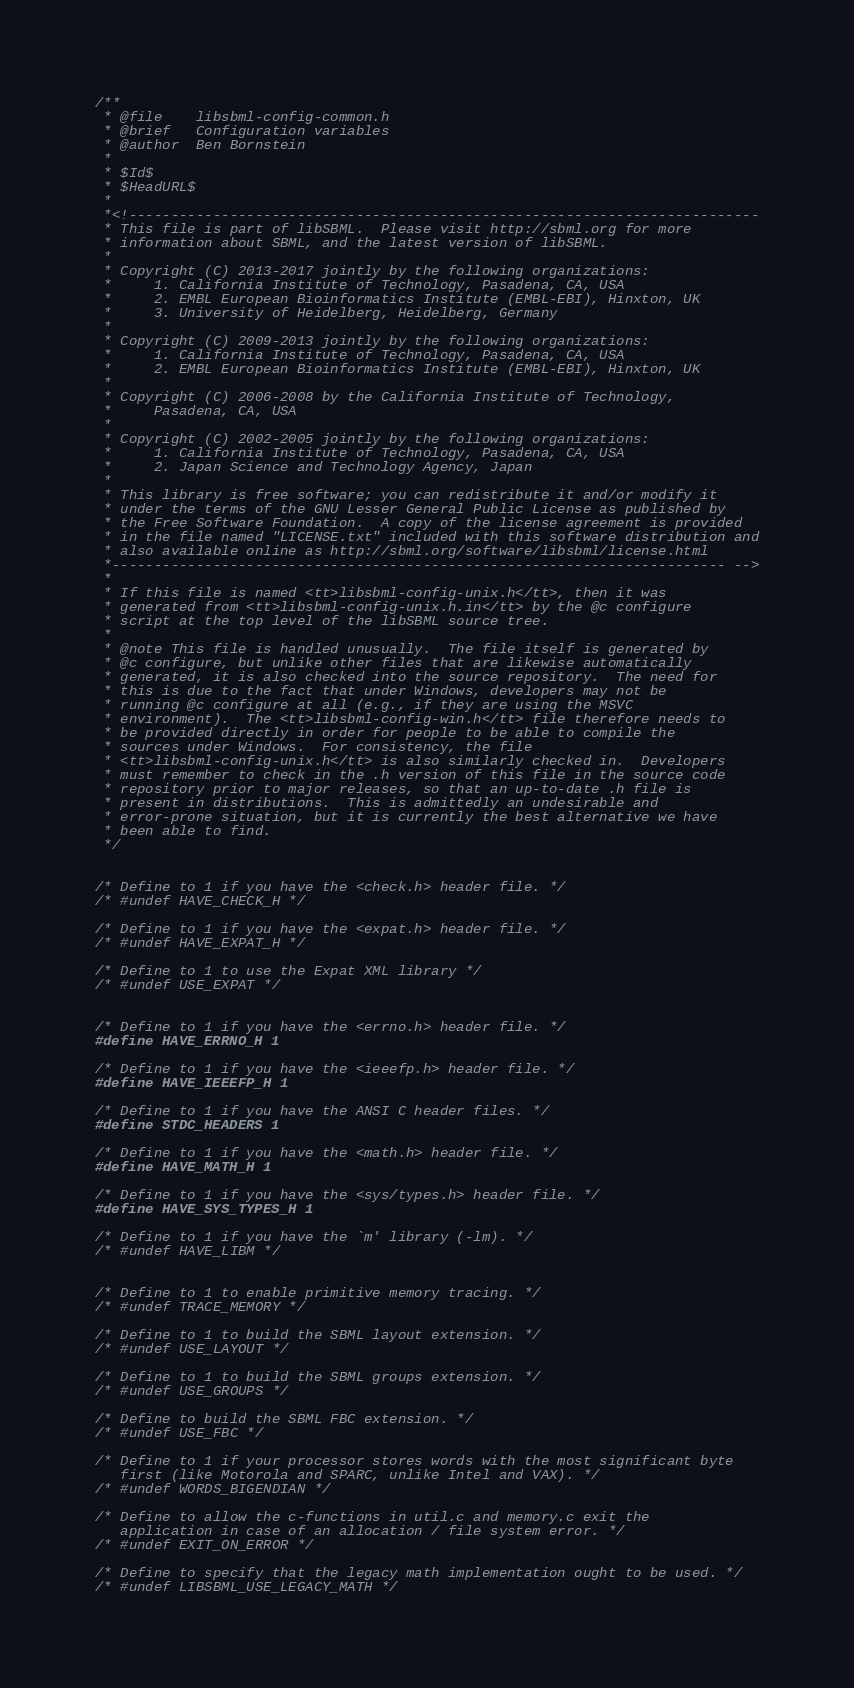Convert code to text. <code><loc_0><loc_0><loc_500><loc_500><_C_>/**
 * @file    libsbml-config-common.h
 * @brief   Configuration variables 
 * @author  Ben Bornstein
 *
 * $Id$
 * $HeadURL$
 *
 *<!---------------------------------------------------------------------------
 * This file is part of libSBML.  Please visit http://sbml.org for more
 * information about SBML, and the latest version of libSBML.
 *
 * Copyright (C) 2013-2017 jointly by the following organizations:
 *     1. California Institute of Technology, Pasadena, CA, USA
 *     2. EMBL European Bioinformatics Institute (EMBL-EBI), Hinxton, UK
 *     3. University of Heidelberg, Heidelberg, Germany
 *
 * Copyright (C) 2009-2013 jointly by the following organizations: 
 *     1. California Institute of Technology, Pasadena, CA, USA
 *     2. EMBL European Bioinformatics Institute (EMBL-EBI), Hinxton, UK
 *  
 * Copyright (C) 2006-2008 by the California Institute of Technology,
 *     Pasadena, CA, USA 
 *  
 * Copyright (C) 2002-2005 jointly by the following organizations: 
 *     1. California Institute of Technology, Pasadena, CA, USA
 *     2. Japan Science and Technology Agency, Japan
 * 
 * This library is free software; you can redistribute it and/or modify it
 * under the terms of the GNU Lesser General Public License as published by
 * the Free Software Foundation.  A copy of the license agreement is provided
 * in the file named "LICENSE.txt" included with this software distribution and
 * also available online as http://sbml.org/software/libsbml/license.html
 *------------------------------------------------------------------------- -->
 *
 * If this file is named <tt>libsbml-config-unix.h</tt>, then it was
 * generated from <tt>libsbml-config-unix.h.in</tt> by the @c configure
 * script at the top level of the libSBML source tree.
 *
 * @note This file is handled unusually.  The file itself is generated by
 * @c configure, but unlike other files that are likewise automatically
 * generated, it is also checked into the source repository.  The need for
 * this is due to the fact that under Windows, developers may not be
 * running @c configure at all (e.g., if they are using the MSVC
 * environment).  The <tt>libsbml-config-win.h</tt> file therefore needs to
 * be provided directly in order for people to be able to compile the
 * sources under Windows.  For consistency, the file
 * <tt>libsbml-config-unix.h</tt> is also similarly checked in.  Developers
 * must remember to check in the .h version of this file in the source code
 * repository prior to major releases, so that an up-to-date .h file is
 * present in distributions.  This is admittedly an undesirable and
 * error-prone situation, but it is currently the best alternative we have
 * been able to find.
 */


/* Define to 1 if you have the <check.h> header file. */
/* #undef HAVE_CHECK_H */

/* Define to 1 if you have the <expat.h> header file. */
/* #undef HAVE_EXPAT_H */

/* Define to 1 to use the Expat XML library */
/* #undef USE_EXPAT */


/* Define to 1 if you have the <errno.h> header file. */
#define HAVE_ERRNO_H 1 

/* Define to 1 if you have the <ieeefp.h> header file. */
#define HAVE_IEEEFP_H 1

/* Define to 1 if you have the ANSI C header files. */
#define STDC_HEADERS 1

/* Define to 1 if you have the <math.h> header file. */
#define HAVE_MATH_H 1

/* Define to 1 if you have the <sys/types.h> header file. */
#define HAVE_SYS_TYPES_H 1

/* Define to 1 if you have the `m' library (-lm). */
/* #undef HAVE_LIBM */


/* Define to 1 to enable primitive memory tracing. */
/* #undef TRACE_MEMORY */

/* Define to 1 to build the SBML layout extension. */
/* #undef USE_LAYOUT */

/* Define to 1 to build the SBML groups extension. */
/* #undef USE_GROUPS */

/* Define to build the SBML FBC extension. */
/* #undef USE_FBC */

/* Define to 1 if your processor stores words with the most significant byte
   first (like Motorola and SPARC, unlike Intel and VAX). */
/* #undef WORDS_BIGENDIAN */

/* Define to allow the c-functions in util.c and memory.c exit the 
   application in case of an allocation / file system error. */
/* #undef EXIT_ON_ERROR */

/* Define to specify that the legacy math implementation ought to be used. */
/* #undef LIBSBML_USE_LEGACY_MATH */
</code> 